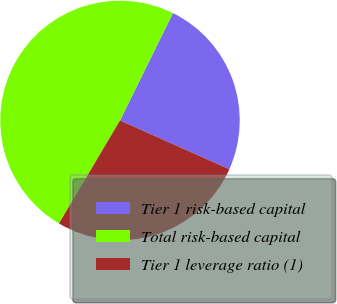Convert chart. <chart><loc_0><loc_0><loc_500><loc_500><pie_chart><fcel>Tier 1 risk-based capital<fcel>Total risk-based capital<fcel>Tier 1 leverage ratio (1)<nl><fcel>24.39%<fcel>48.78%<fcel>26.83%<nl></chart> 